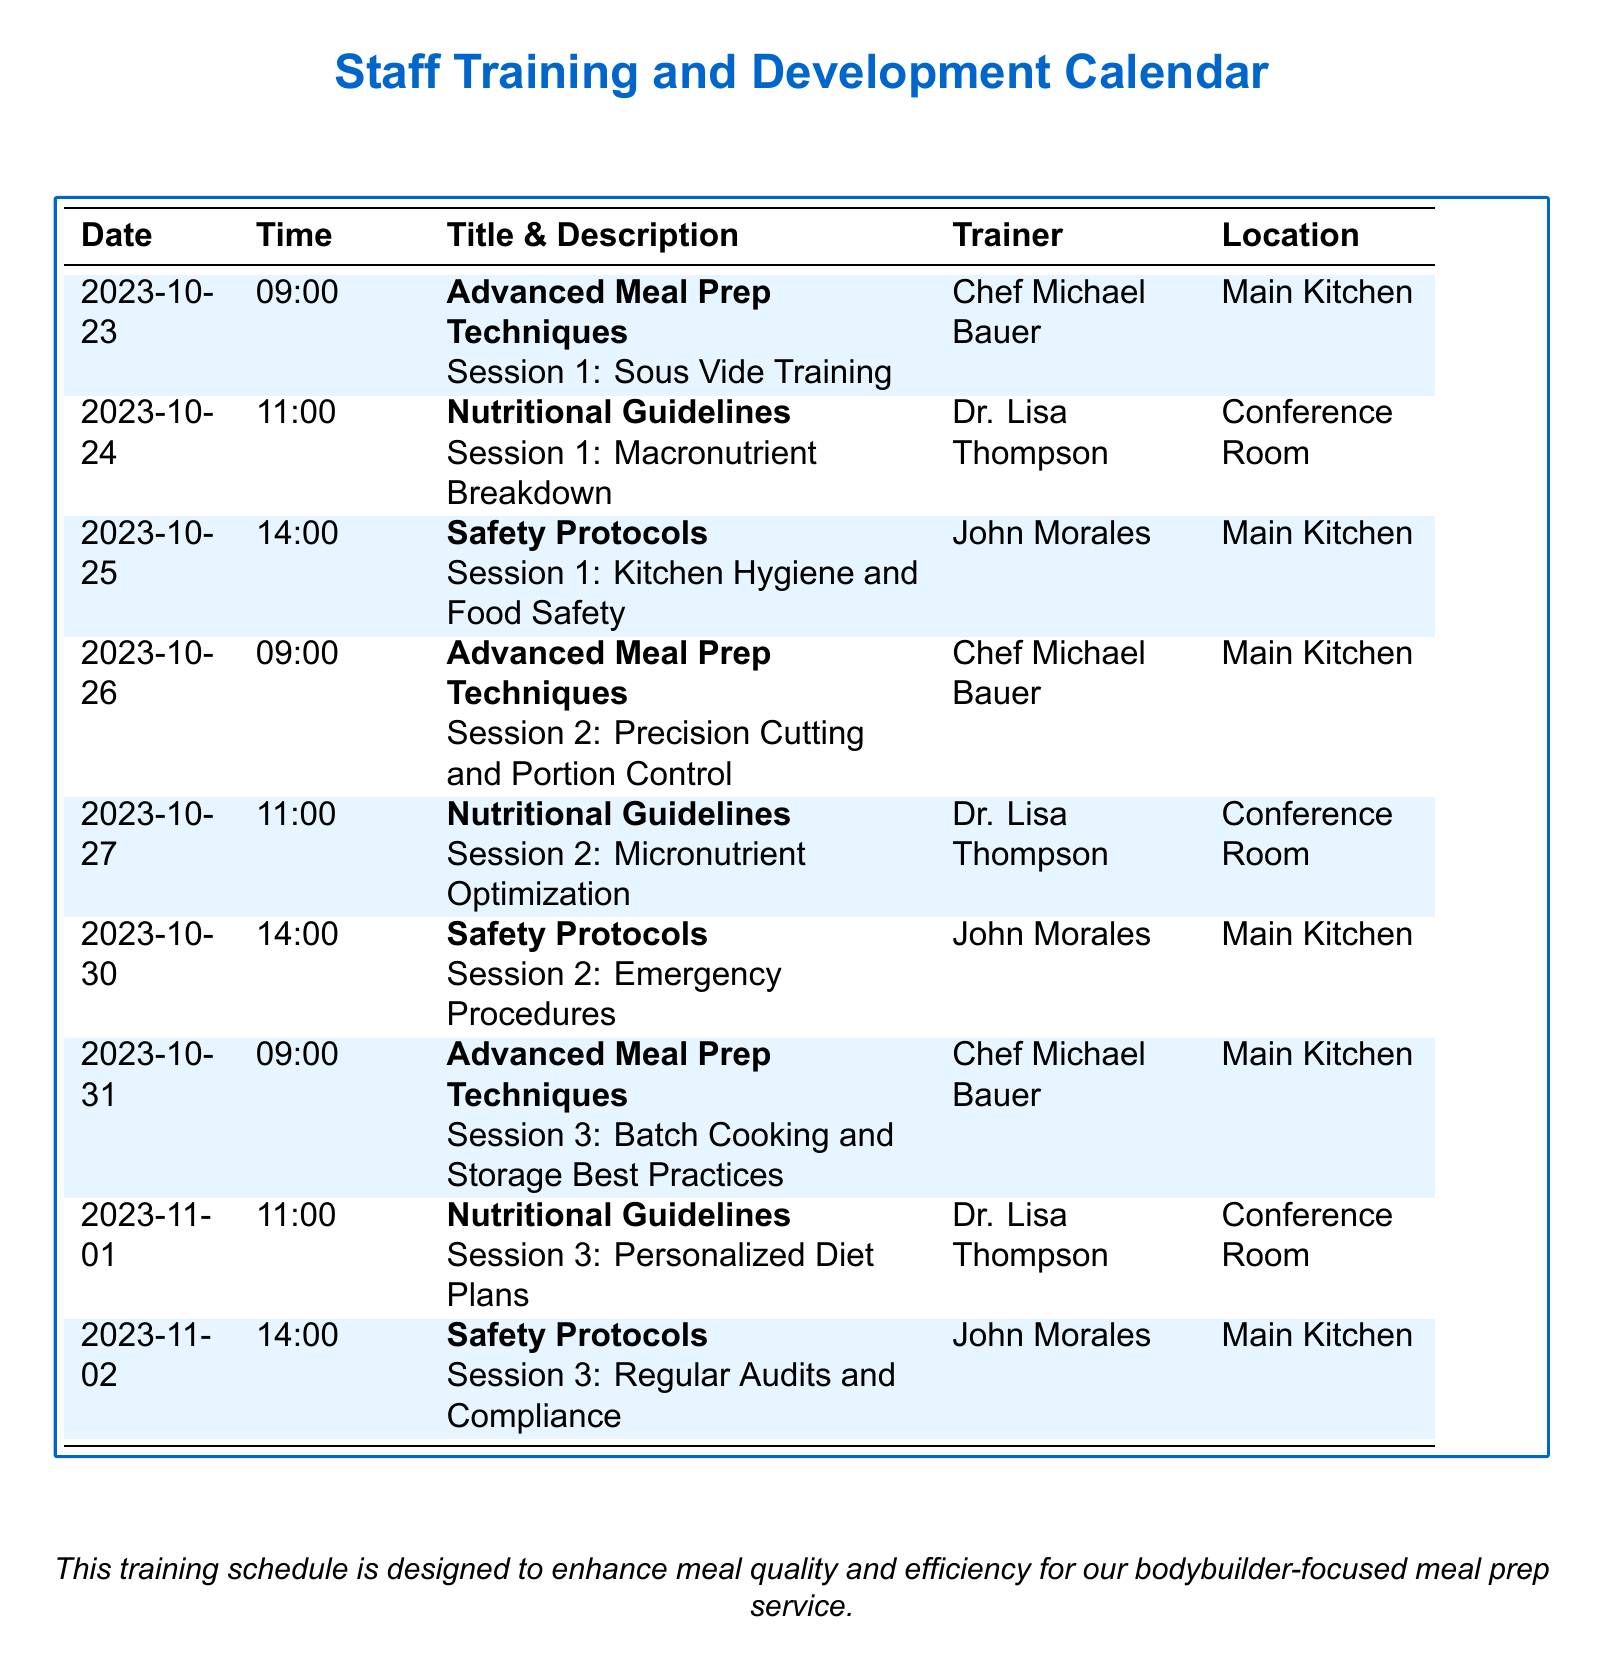What is the date of the first training session? The date of the first training session can be found in the "Date" column, which shows October 23, 2023.
Answer: October 23, 2023 Who is the trainer for the Nutritional Guidelines session 2? The trainer's name for session 2 in the Nutritional Guidelines category is shown in the "Trainer" column, which lists Dr. Lisa Thompson.
Answer: Dr. Lisa Thompson What time does the Safety Protocols session 3 start? The start time for Safety Protocols session 3 is recorded in the "Time" column, specifically showing 14:00.
Answer: 14:00 How many Advanced Meal Prep Techniques sessions are scheduled? The number of sessions in the Advanced Meal Prep Techniques category can be counted from the "Title & Description" column, totaling three sessions.
Answer: 3 What topic is covered in Safety Protocols session 2? The topic of Safety Protocols session 2 is detailed in the "Title & Description" column, specifying 'Emergency Procedures.'
Answer: Emergency Procedures Where is the location for the training on Precision Cutting and Portion Control? The location for the training on Precision Cutting and Portion Control is noted in the "Location" column, which states 'Main Kitchen.'
Answer: Main Kitchen What is the focus of the Nutritional Guidelines session 3? The focus of Nutritional Guidelines session 3 is highlighted in the "Title & Description" column, indicating 'Personalized Diet Plans.'
Answer: Personalized Diet Plans 